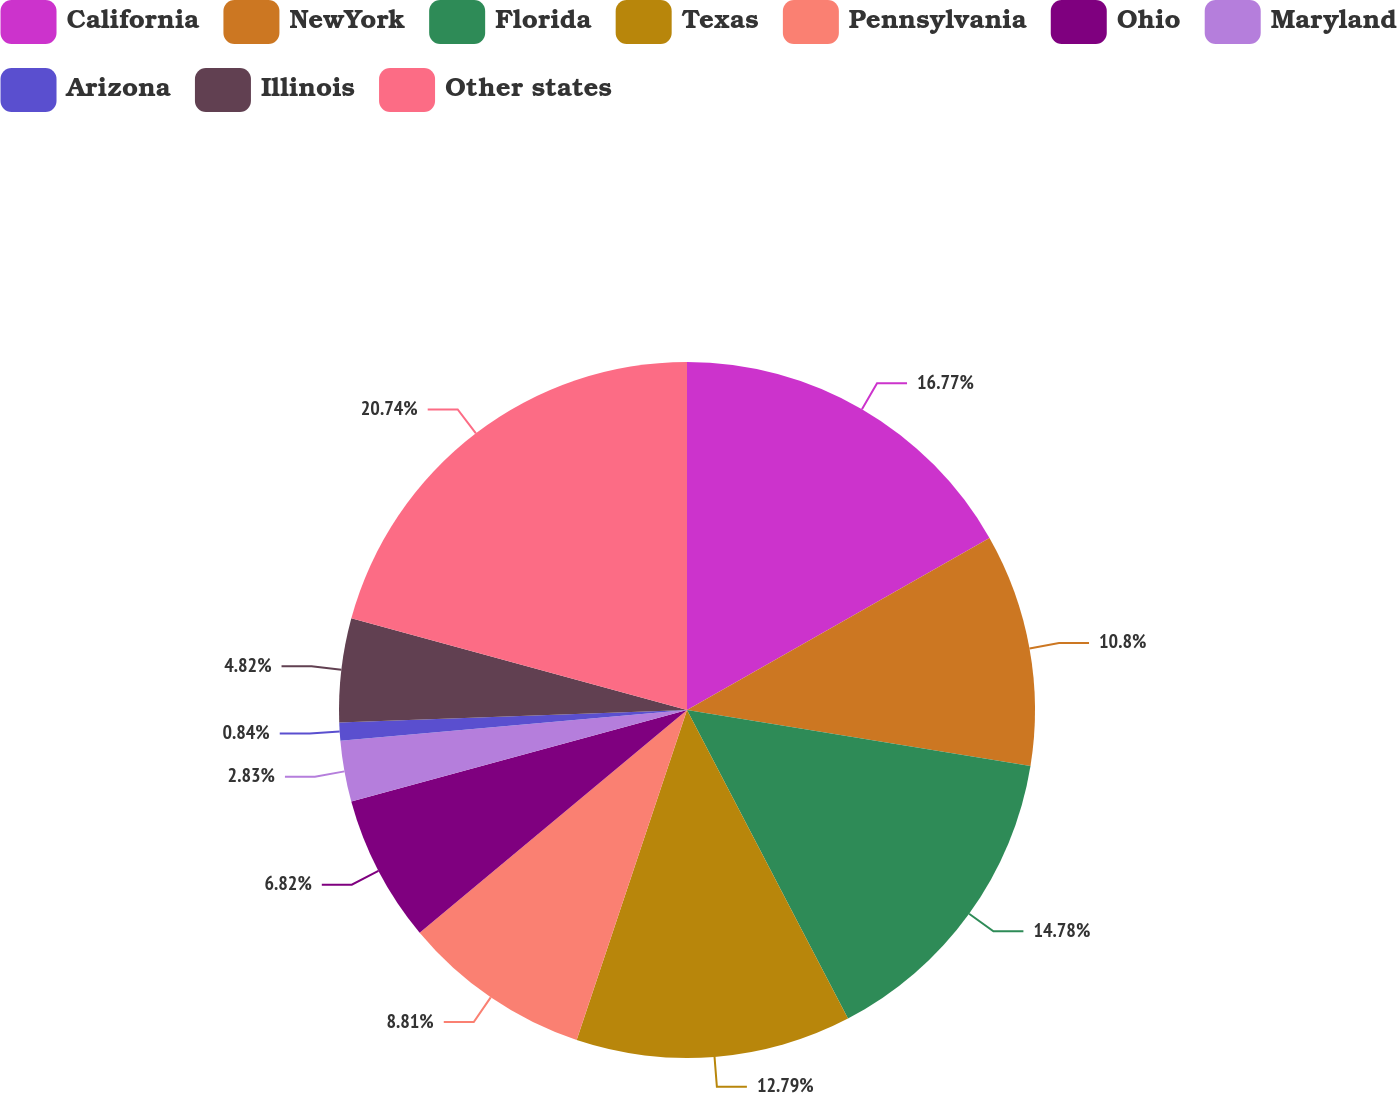Convert chart. <chart><loc_0><loc_0><loc_500><loc_500><pie_chart><fcel>California<fcel>NewYork<fcel>Florida<fcel>Texas<fcel>Pennsylvania<fcel>Ohio<fcel>Maryland<fcel>Arizona<fcel>Illinois<fcel>Other states<nl><fcel>16.77%<fcel>10.8%<fcel>14.78%<fcel>12.79%<fcel>8.81%<fcel>6.82%<fcel>2.83%<fcel>0.84%<fcel>4.82%<fcel>20.75%<nl></chart> 